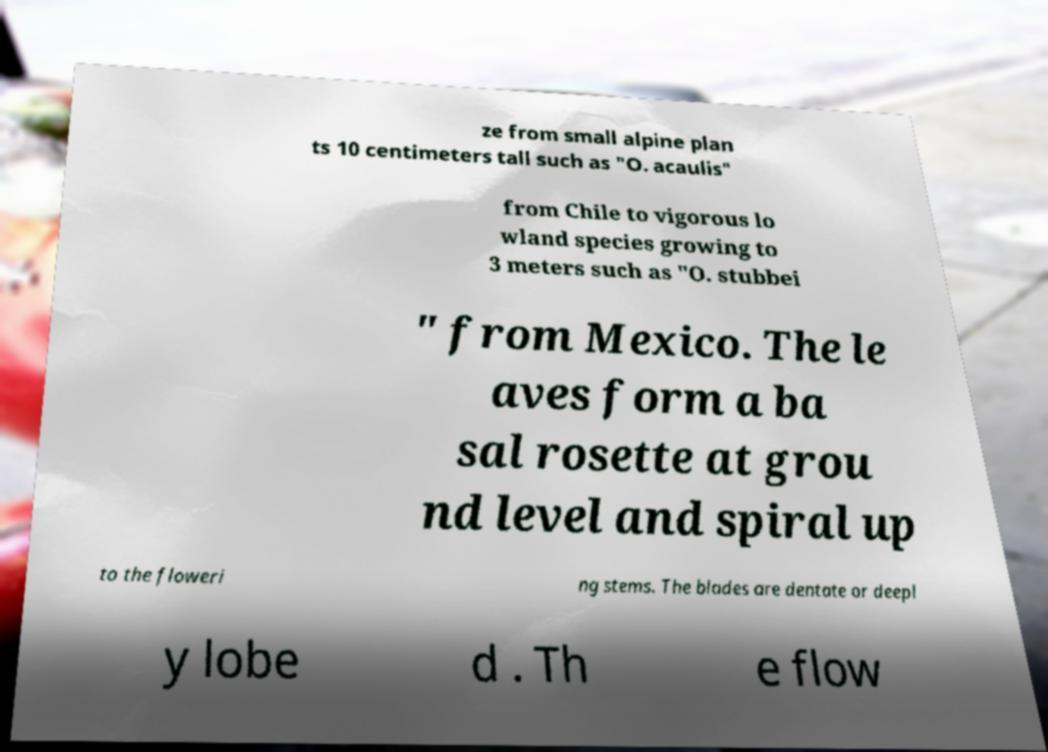There's text embedded in this image that I need extracted. Can you transcribe it verbatim? ze from small alpine plan ts 10 centimeters tall such as "O. acaulis" from Chile to vigorous lo wland species growing to 3 meters such as "O. stubbei " from Mexico. The le aves form a ba sal rosette at grou nd level and spiral up to the floweri ng stems. The blades are dentate or deepl y lobe d . Th e flow 